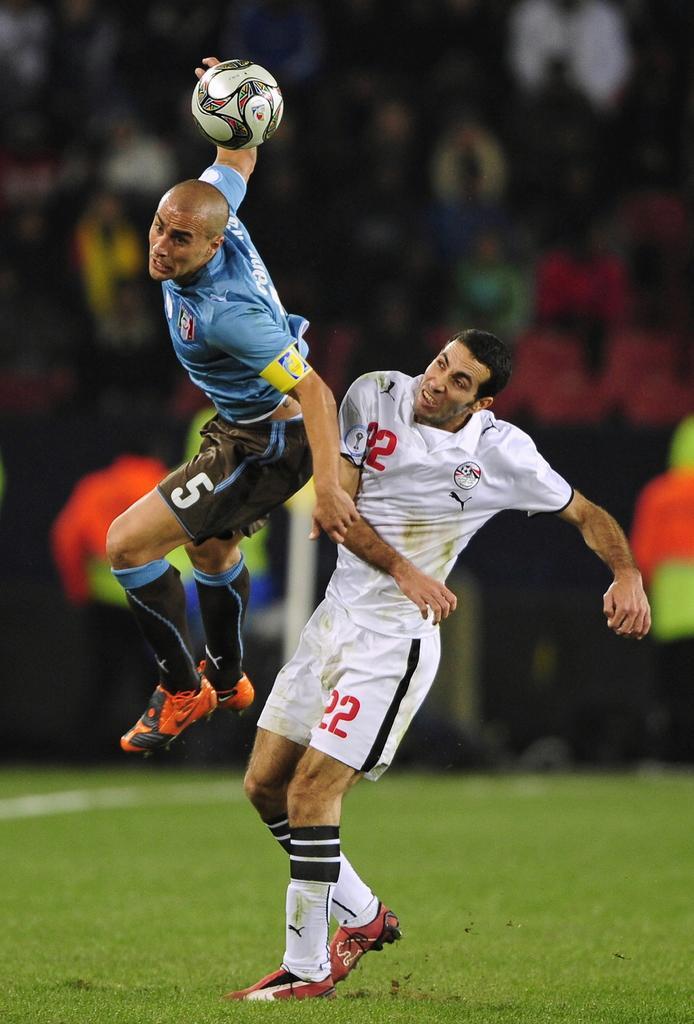In one or two sentences, can you explain what this image depicts? In this image I see 2 men, in which one of them is in air and another one is on the grass. I also see that there is a ball over here. 